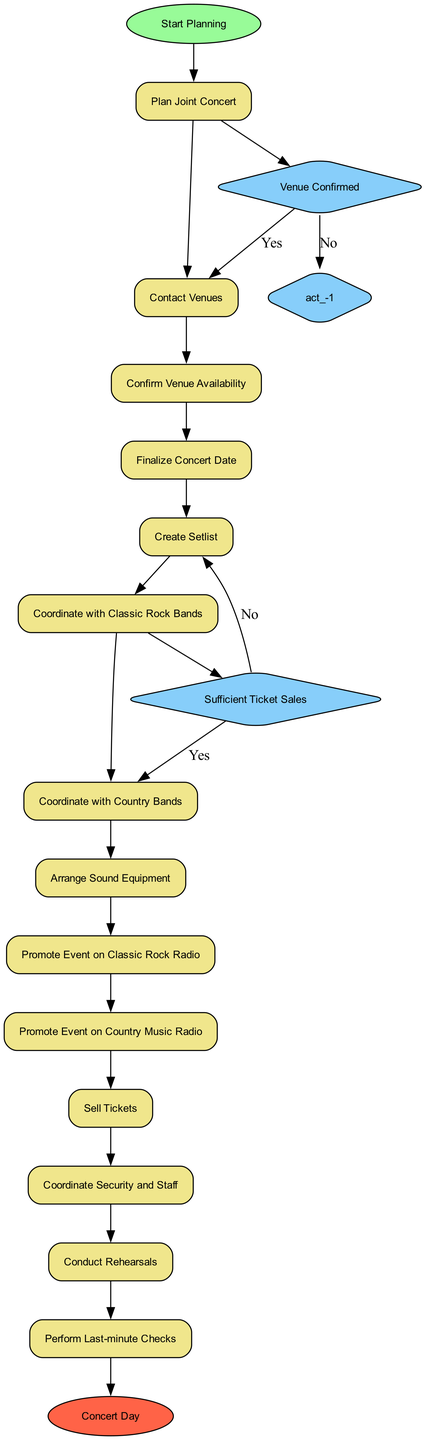What is the starting point of the activity diagram? The starting point, labeled as "Start Planning," indicates where the process begins. This is a common feature in activity diagrams to establish the initial state.
Answer: Start Planning What activity comes after "Contact Venues"? After "Contact Venues," the next activity in the sequence is "Confirm Venue Availability." The diagram shows a linear flow between these activities.
Answer: Confirm Venue Availability How many decision nodes are in the diagram? The diagram contains two decision nodes: "Venue Confirmed" and "Sufficient Ticket Sales." Decision nodes differentiate between different paths based on the outcomes.
Answer: 2 What activity occurs before "Create Setlist"? The activity that occurs before "Create Setlist" is "Finalize Concert Date." The sequence flows directly from finalizing the date to creating the setlist.
Answer: Finalize Concert Date Which activity is linked to the decision node "Venue Confirmed"? The activity linked to the decision node "Venue Confirmed" is "Finalize Concert Date" if the venue is confirmed; otherwise, it reverts to "Contact Venues." This shows the contingency based on the decision outcome.
Answer: Finalize Concert Date What happens if "Sufficient Ticket Sales" is answered as 'No'? If "Sufficient Ticket Sales" is answered as 'No,' the flow returns to "Promote Event on Classic Rock Radio," indicating a need to enhance ticket promotion efforts. This reflects the iterative nature of the concert planning process.
Answer: Promote Event on Classic Rock Radio What activity precedes "Conduct Rehearsals"? The activity preceding "Conduct Rehearsals" is "Coordinate Security and Staff," which is important for ensuring that all logistical aspects are in place before rehearsals.
Answer: Coordinate Security and Staff What is the final activity before the concert day? The final activity before reaching the "Concert Day" is "Perform Last-minute Checks," which is essential for ensuring everything is set before the event occurs.
Answer: Perform Last-minute Checks 